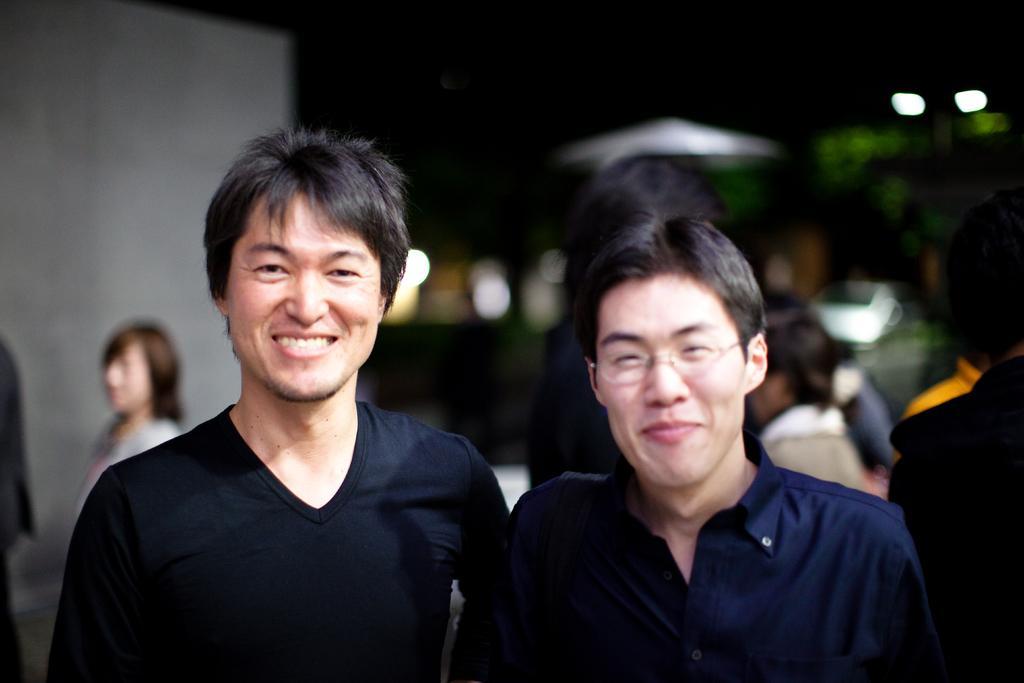In one or two sentences, can you explain what this image depicts? In this picture I can see the two men in the middle, they are smiling. In the the background there are few persons, on the right side there are lights. 